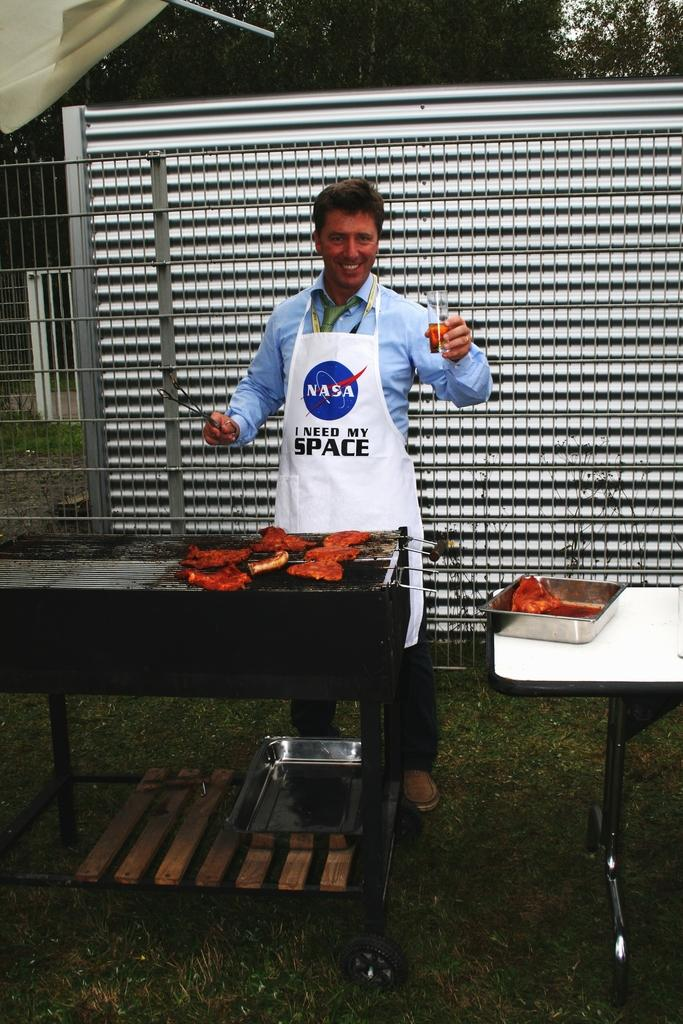<image>
Offer a succinct explanation of the picture presented. A man is cooking at a barbecue with a NASA apron that says I Need My Space. 